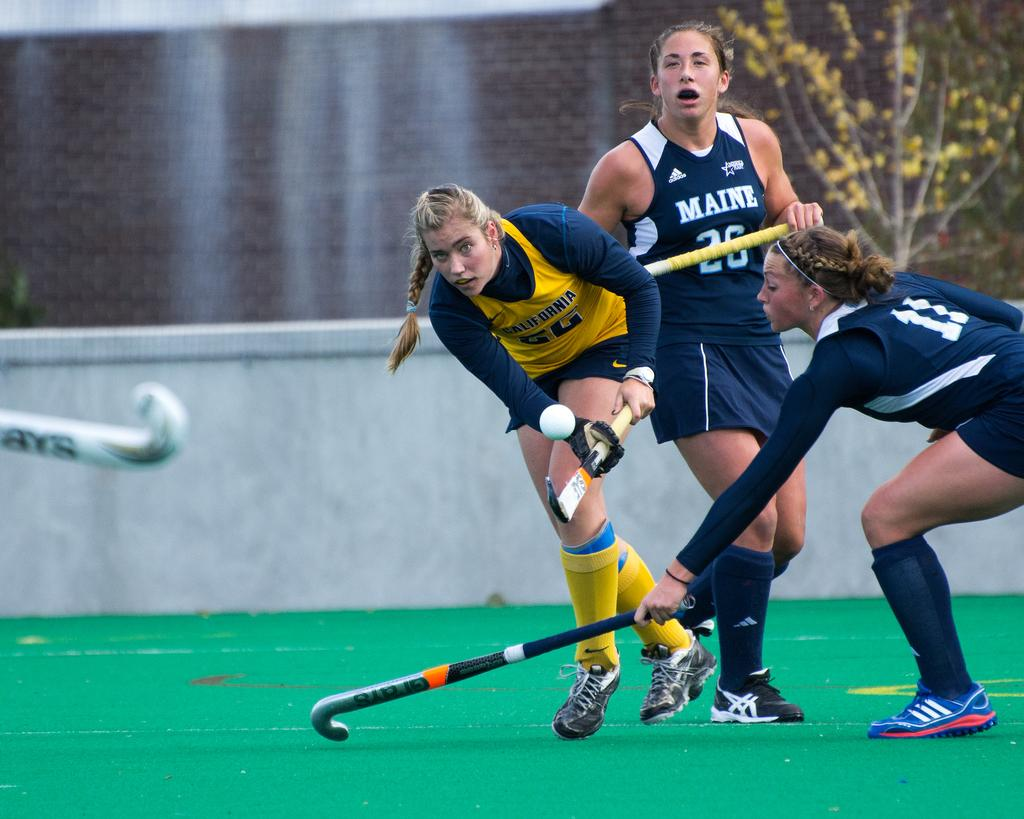How many people are in the image? There are three persons in the image. What are the persons holding in the image? The persons are holding hockey sticks. What activity are the persons engaged in? The persons are playing hockey. Can you describe any other objects or features in the image? There is a plant in the top right of the image and a wall in the middle of the image. What type of wood is the scarecrow made of in the image? There is no scarecrow present in the image, so it is not possible to determine what type of wood it might be made of. 